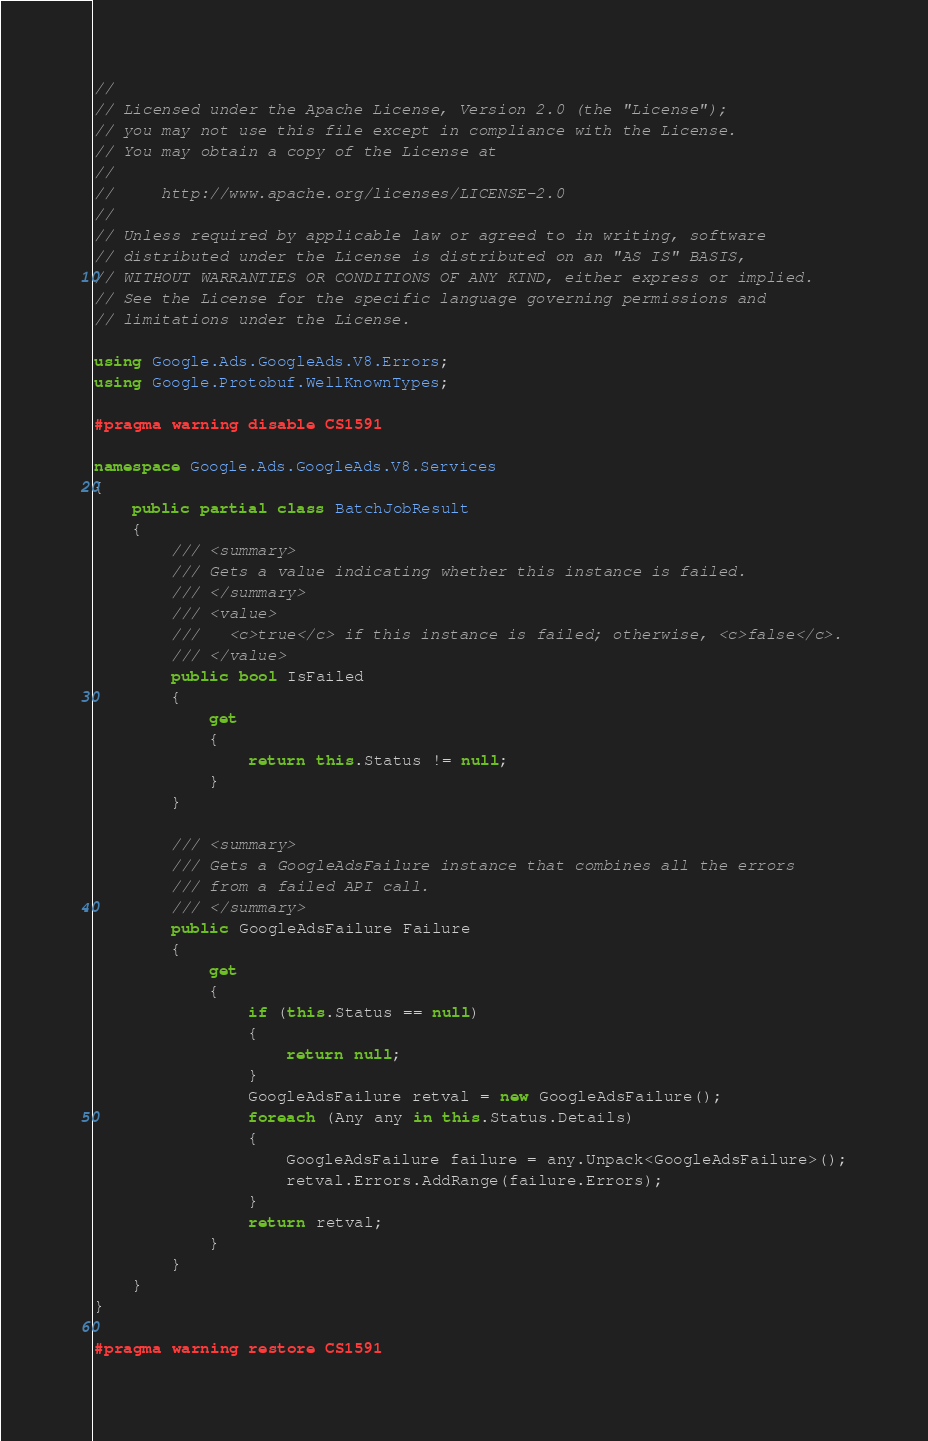Convert code to text. <code><loc_0><loc_0><loc_500><loc_500><_C#_>//
// Licensed under the Apache License, Version 2.0 (the "License");
// you may not use this file except in compliance with the License.
// You may obtain a copy of the License at
//
//     http://www.apache.org/licenses/LICENSE-2.0
//
// Unless required by applicable law or agreed to in writing, software
// distributed under the License is distributed on an "AS IS" BASIS,
// WITHOUT WARRANTIES OR CONDITIONS OF ANY KIND, either express or implied.
// See the License for the specific language governing permissions and
// limitations under the License.

using Google.Ads.GoogleAds.V8.Errors;
using Google.Protobuf.WellKnownTypes;

#pragma warning disable CS1591

namespace Google.Ads.GoogleAds.V8.Services
{
    public partial class BatchJobResult
    {
        /// <summary>
        /// Gets a value indicating whether this instance is failed.
        /// </summary>
        /// <value>
        ///   <c>true</c> if this instance is failed; otherwise, <c>false</c>.
        /// </value>
        public bool IsFailed
        {
            get
            {
                return this.Status != null;
            }
        }

        /// <summary>
        /// Gets a GoogleAdsFailure instance that combines all the errors
        /// from a failed API call.
        /// </summary>
        public GoogleAdsFailure Failure
        {
            get
            {
                if (this.Status == null)
                {
                    return null;
                }
                GoogleAdsFailure retval = new GoogleAdsFailure();
                foreach (Any any in this.Status.Details)
                {
                    GoogleAdsFailure failure = any.Unpack<GoogleAdsFailure>();
                    retval.Errors.AddRange(failure.Errors);
                }
                return retval;
            }
        }
    }
}

#pragma warning restore CS1591
</code> 